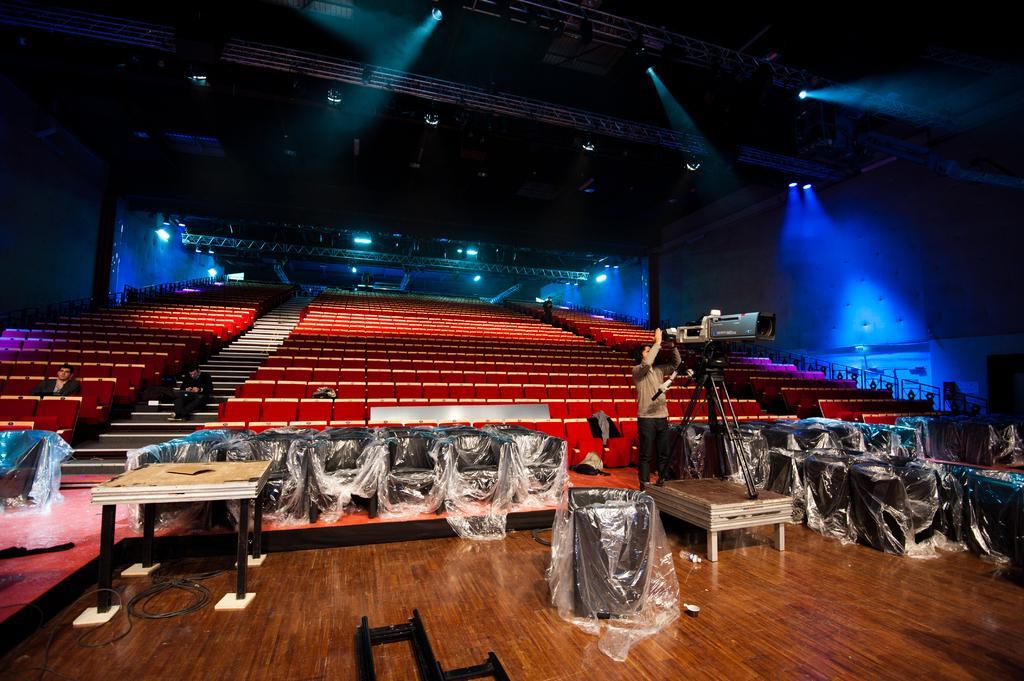In one or two sentences, can you explain what this image depicts? To the bottom of the image there is a floor. On the floor to the left side there is a table. And also in the middle there are black chairs which are covered with covers. In the middle of them there is a man standing in front of the video camera with a stand. In the background there are many red chairs. And to the top of the image there is a roof with rods and lights. 